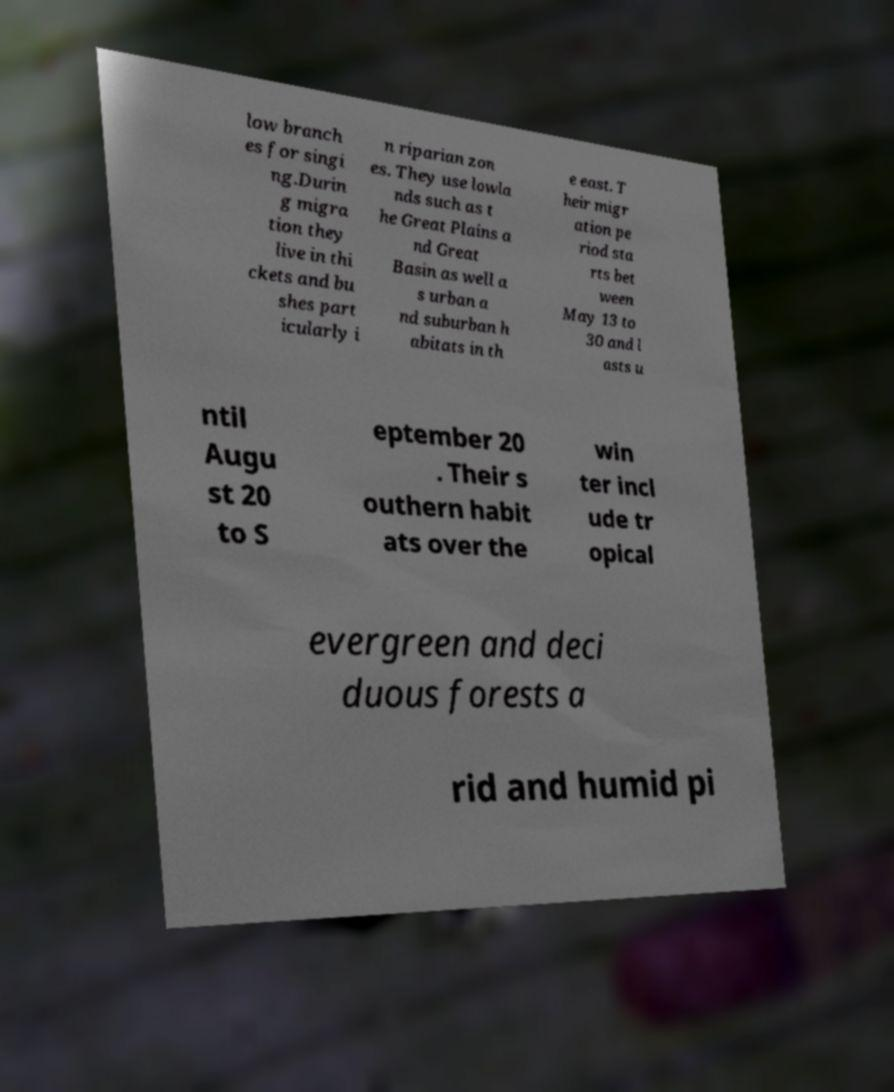For documentation purposes, I need the text within this image transcribed. Could you provide that? low branch es for singi ng.Durin g migra tion they live in thi ckets and bu shes part icularly i n riparian zon es. They use lowla nds such as t he Great Plains a nd Great Basin as well a s urban a nd suburban h abitats in th e east. T heir migr ation pe riod sta rts bet ween May 13 to 30 and l asts u ntil Augu st 20 to S eptember 20 . Their s outhern habit ats over the win ter incl ude tr opical evergreen and deci duous forests a rid and humid pi 